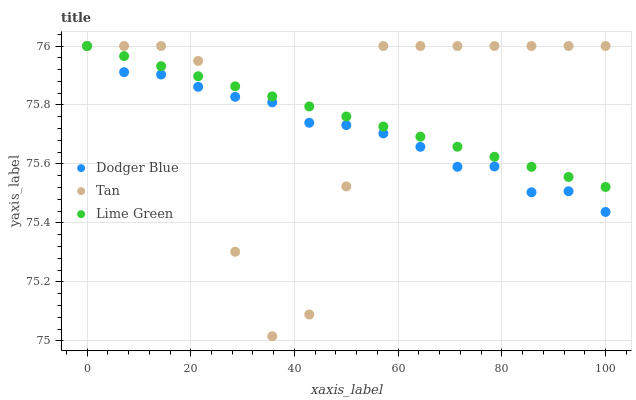Does Dodger Blue have the minimum area under the curve?
Answer yes or no. Yes. Does Tan have the maximum area under the curve?
Answer yes or no. Yes. Does Tan have the minimum area under the curve?
Answer yes or no. No. Does Dodger Blue have the maximum area under the curve?
Answer yes or no. No. Is Lime Green the smoothest?
Answer yes or no. Yes. Is Tan the roughest?
Answer yes or no. Yes. Is Dodger Blue the smoothest?
Answer yes or no. No. Is Dodger Blue the roughest?
Answer yes or no. No. Does Tan have the lowest value?
Answer yes or no. Yes. Does Dodger Blue have the lowest value?
Answer yes or no. No. Does Dodger Blue have the highest value?
Answer yes or no. Yes. Does Tan intersect Dodger Blue?
Answer yes or no. Yes. Is Tan less than Dodger Blue?
Answer yes or no. No. Is Tan greater than Dodger Blue?
Answer yes or no. No. 